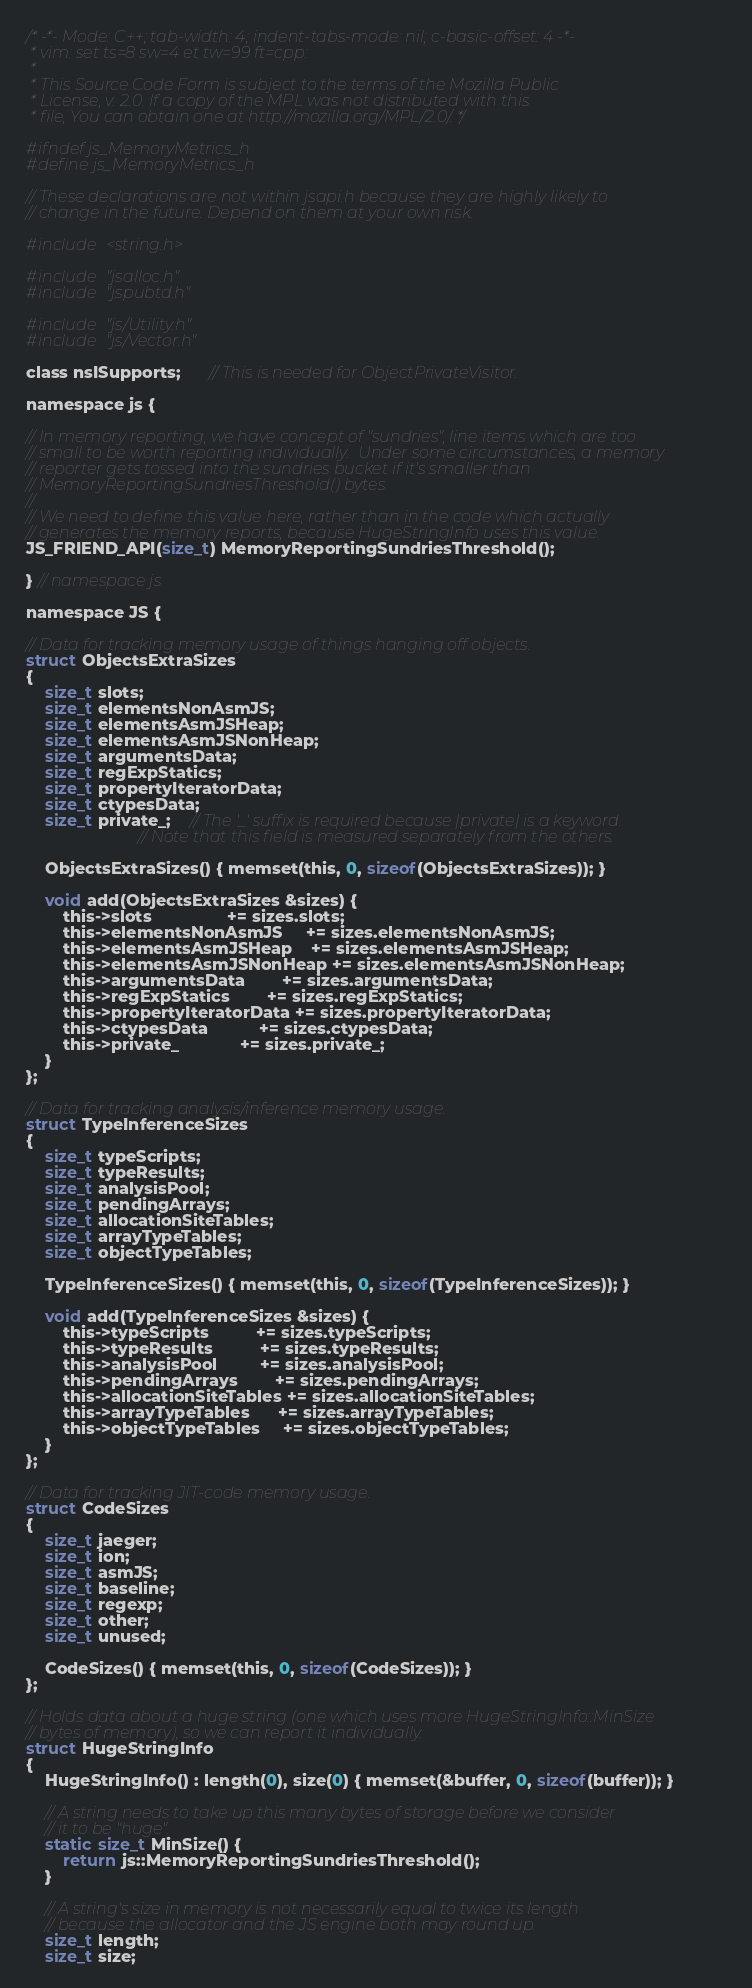Convert code to text. <code><loc_0><loc_0><loc_500><loc_500><_C_>/* -*- Mode: C++; tab-width: 4; indent-tabs-mode: nil; c-basic-offset: 4 -*-
 * vim: set ts=8 sw=4 et tw=99 ft=cpp:
 *
 * This Source Code Form is subject to the terms of the Mozilla Public
 * License, v. 2.0. If a copy of the MPL was not distributed with this
 * file, You can obtain one at http://mozilla.org/MPL/2.0/. */

#ifndef js_MemoryMetrics_h
#define js_MemoryMetrics_h

// These declarations are not within jsapi.h because they are highly likely to
// change in the future. Depend on them at your own risk.

#include <string.h>

#include "jsalloc.h"
#include "jspubtd.h"

#include "js/Utility.h"
#include "js/Vector.h"

class nsISupports;      // This is needed for ObjectPrivateVisitor.

namespace js {

// In memory reporting, we have concept of "sundries", line items which are too
// small to be worth reporting individually.  Under some circumstances, a memory
// reporter gets tossed into the sundries bucket if it's smaller than
// MemoryReportingSundriesThreshold() bytes.
//
// We need to define this value here, rather than in the code which actually
// generates the memory reports, because HugeStringInfo uses this value.
JS_FRIEND_API(size_t) MemoryReportingSundriesThreshold();

} // namespace js

namespace JS {

// Data for tracking memory usage of things hanging off objects.
struct ObjectsExtraSizes
{
    size_t slots;
    size_t elementsNonAsmJS;
    size_t elementsAsmJSHeap;
    size_t elementsAsmJSNonHeap;
    size_t argumentsData;
    size_t regExpStatics;
    size_t propertyIteratorData;
    size_t ctypesData;
    size_t private_;    // The '_' suffix is required because |private| is a keyword.
                        // Note that this field is measured separately from the others.

    ObjectsExtraSizes() { memset(this, 0, sizeof(ObjectsExtraSizes)); }

    void add(ObjectsExtraSizes &sizes) {
        this->slots                += sizes.slots;
        this->elementsNonAsmJS     += sizes.elementsNonAsmJS;
        this->elementsAsmJSHeap    += sizes.elementsAsmJSHeap;
        this->elementsAsmJSNonHeap += sizes.elementsAsmJSNonHeap;
        this->argumentsData        += sizes.argumentsData;
        this->regExpStatics        += sizes.regExpStatics;
        this->propertyIteratorData += sizes.propertyIteratorData;
        this->ctypesData           += sizes.ctypesData;
        this->private_             += sizes.private_;
    }
};

// Data for tracking analysis/inference memory usage.
struct TypeInferenceSizes
{
    size_t typeScripts;
    size_t typeResults;
    size_t analysisPool;
    size_t pendingArrays;
    size_t allocationSiteTables;
    size_t arrayTypeTables;
    size_t objectTypeTables;

    TypeInferenceSizes() { memset(this, 0, sizeof(TypeInferenceSizes)); }

    void add(TypeInferenceSizes &sizes) {
        this->typeScripts          += sizes.typeScripts;
        this->typeResults          += sizes.typeResults;
        this->analysisPool         += sizes.analysisPool;
        this->pendingArrays        += sizes.pendingArrays;
        this->allocationSiteTables += sizes.allocationSiteTables;
        this->arrayTypeTables      += sizes.arrayTypeTables;
        this->objectTypeTables     += sizes.objectTypeTables;
    }
};

// Data for tracking JIT-code memory usage.
struct CodeSizes
{
    size_t jaeger;
    size_t ion;
    size_t asmJS;
    size_t baseline;
    size_t regexp;
    size_t other;
    size_t unused;

    CodeSizes() { memset(this, 0, sizeof(CodeSizes)); }
};

// Holds data about a huge string (one which uses more HugeStringInfo::MinSize
// bytes of memory), so we can report it individually.
struct HugeStringInfo
{
    HugeStringInfo() : length(0), size(0) { memset(&buffer, 0, sizeof(buffer)); }

    // A string needs to take up this many bytes of storage before we consider
    // it to be "huge".
    static size_t MinSize() {
        return js::MemoryReportingSundriesThreshold();
    }

    // A string's size in memory is not necessarily equal to twice its length
    // because the allocator and the JS engine both may round up.
    size_t length;
    size_t size;
</code> 